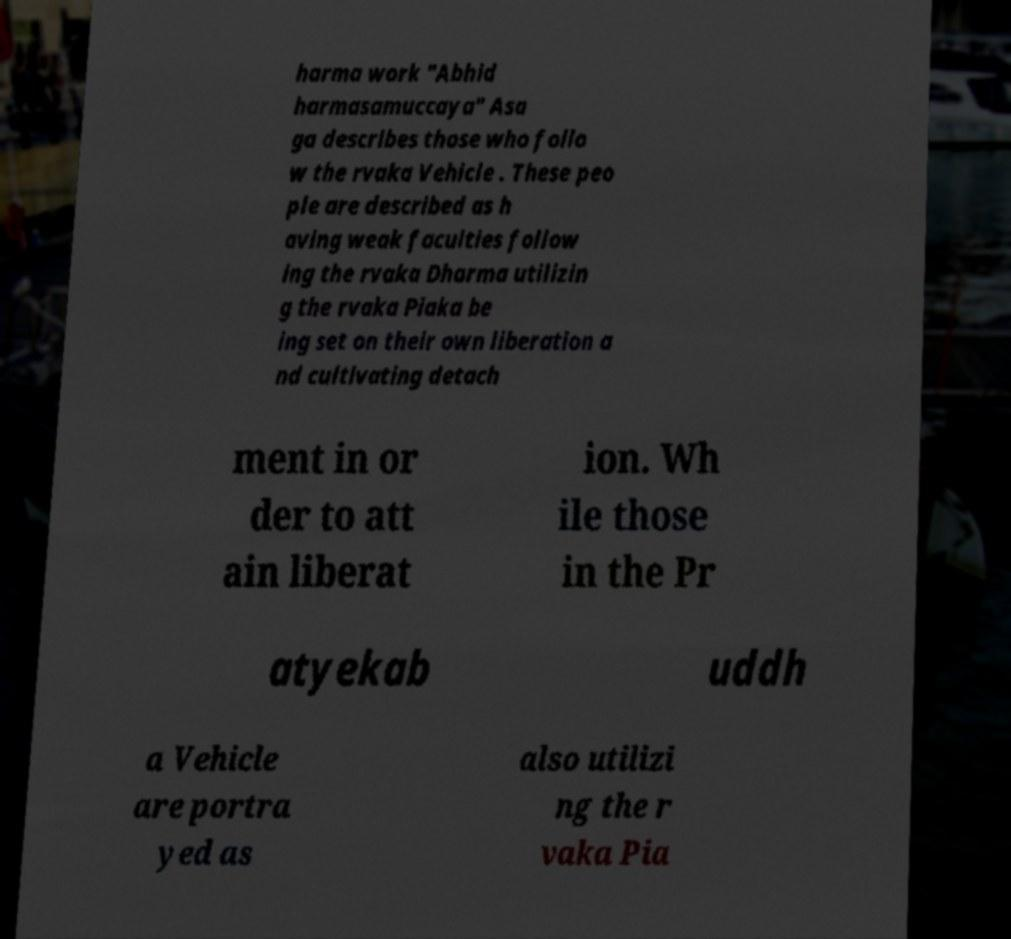Can you read and provide the text displayed in the image?This photo seems to have some interesting text. Can you extract and type it out for me? harma work "Abhid harmasamuccaya" Asa ga describes those who follo w the rvaka Vehicle . These peo ple are described as h aving weak faculties follow ing the rvaka Dharma utilizin g the rvaka Piaka be ing set on their own liberation a nd cultivating detach ment in or der to att ain liberat ion. Wh ile those in the Pr atyekab uddh a Vehicle are portra yed as also utilizi ng the r vaka Pia 